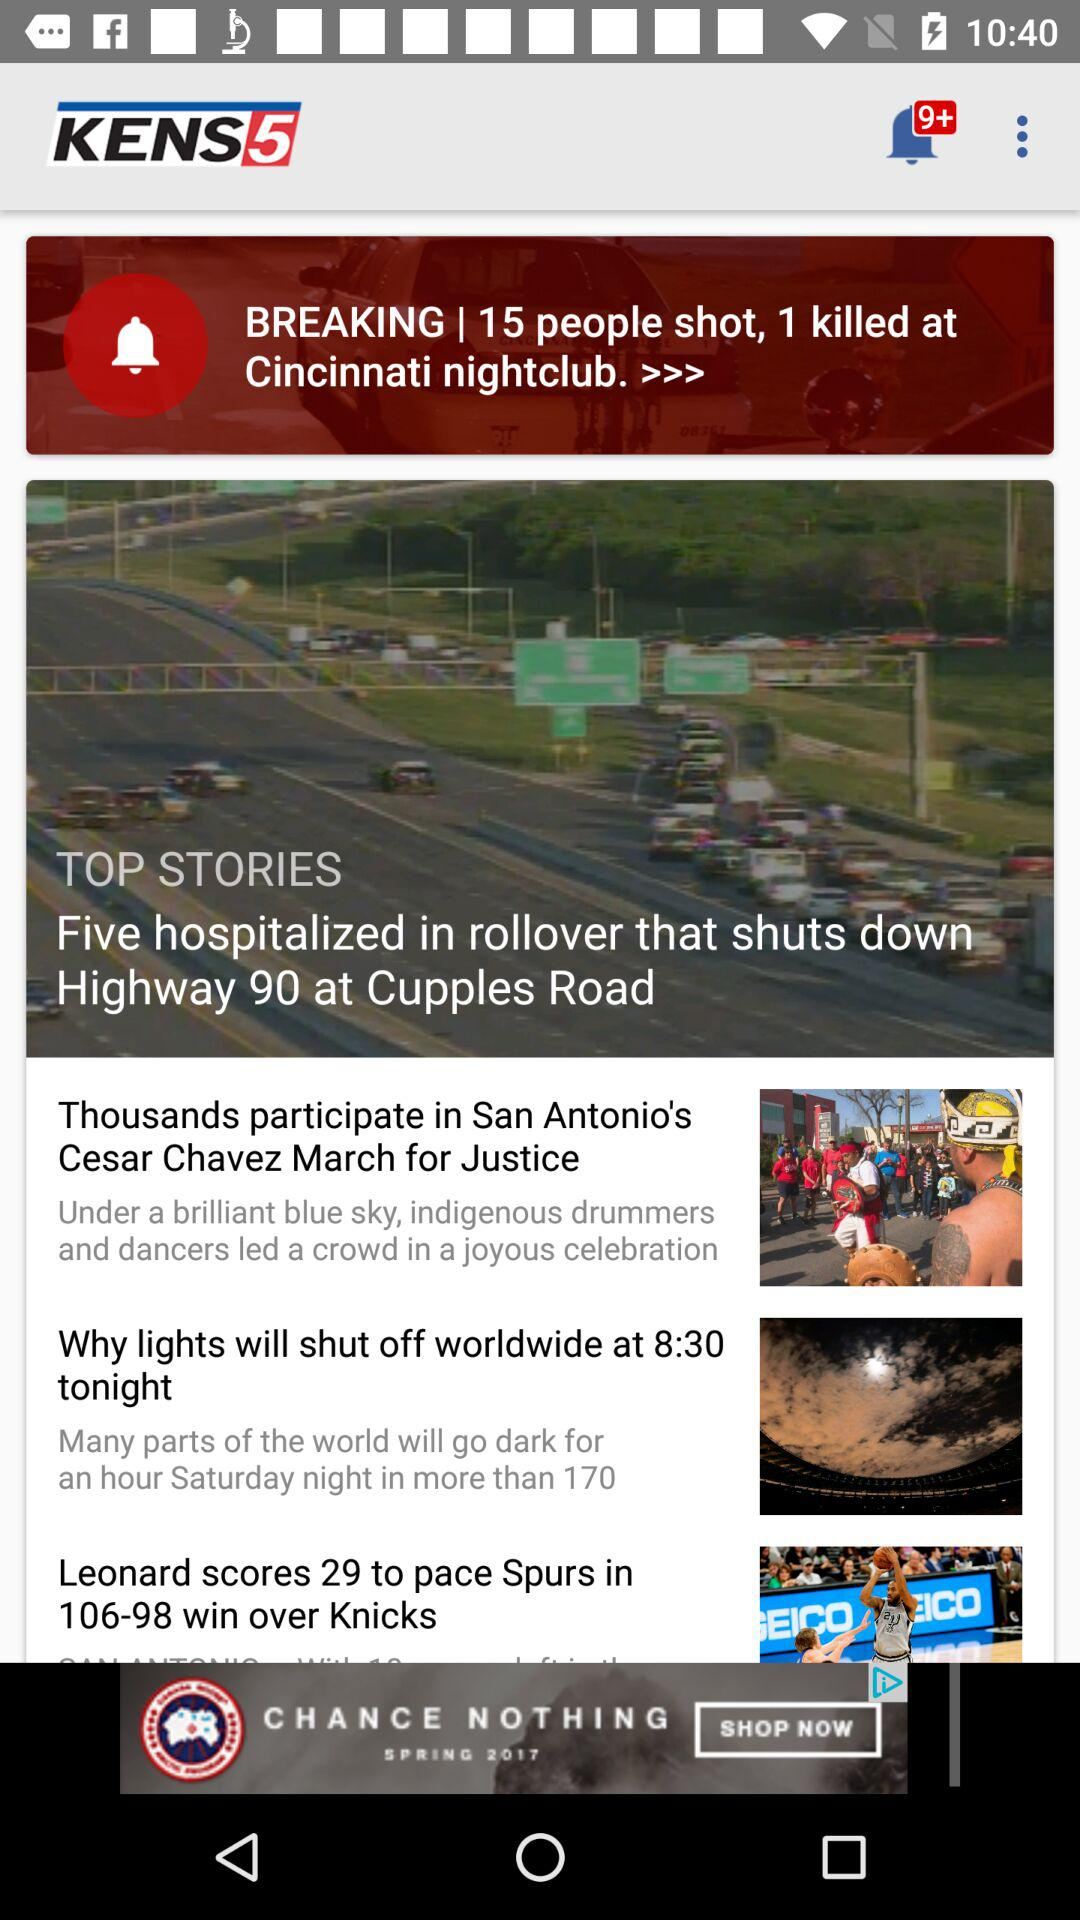How many people are shot in "Cincinnati nightclub"? There are 15 people shot in "Cincinnati nightclub". 